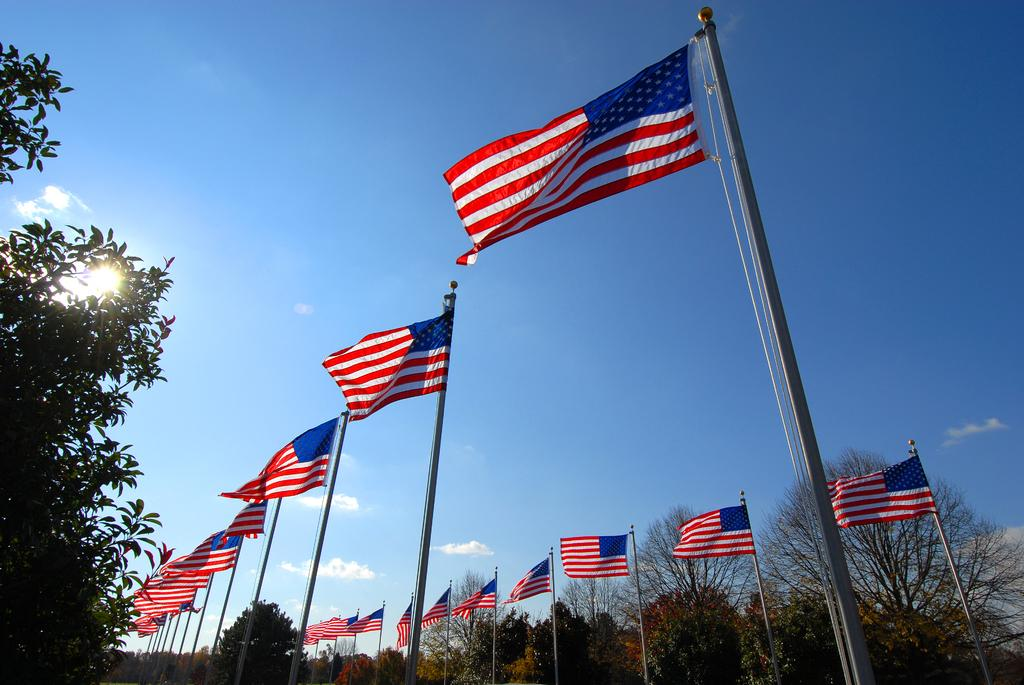What type of natural elements can be seen in the image? There are trees in the image. What man-made objects are present in the image? There are flags in the image. What celestial body is visible in the image? The sun is visible in the image. What part of the natural environment is visible in the image? The sky is visible in the image. What atmospheric conditions can be observed in the image? There are clouds in the image. What type of sheet is being used to exchange information on the board in the image? There is no sheet, exchange, or board present in the image. What type of board game is being played in the image? There is no board game present in the image. 